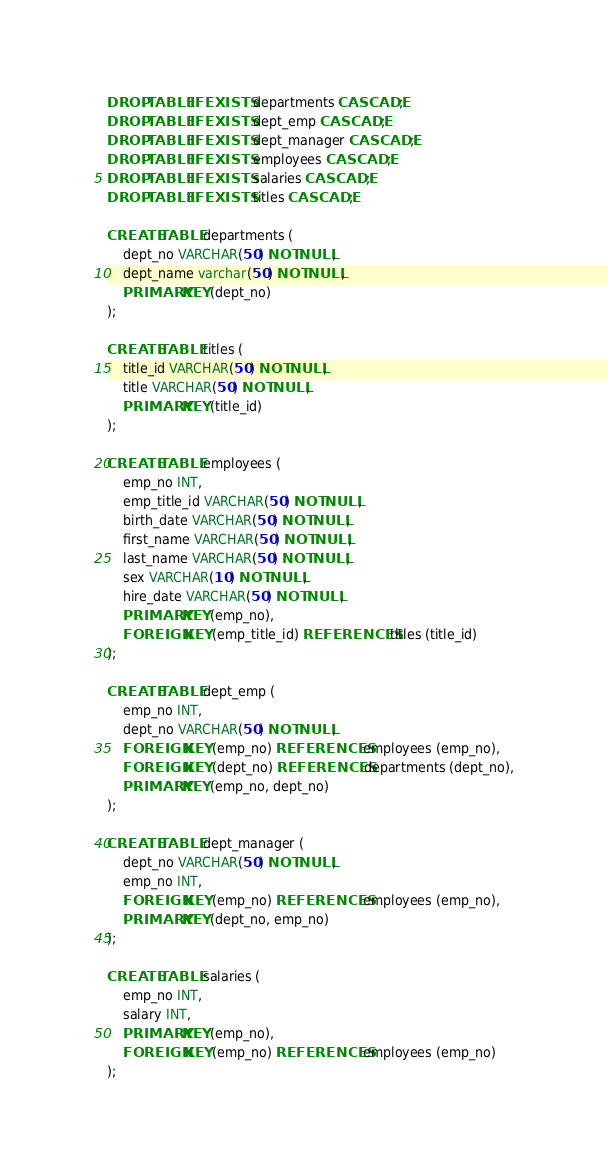<code> <loc_0><loc_0><loc_500><loc_500><_SQL_>DROP TABLE IF EXISTS departments CASCADE;
DROP TABLE IF EXISTS dept_emp CASCADE;
DROP TABLE IF EXISTS dept_manager CASCADE;
DROP TABLE IF EXISTS employees CASCADE;
DROP TABLE IF EXISTS salaries CASCADE;
DROP TABLE IF EXISTS titles CASCADE;

CREATE TABLE departments (
    dept_no VARCHAR(50) NOT NULL,
    dept_name varchar(50) NOT NULL,
	PRIMARY KEY (dept_no)
);

CREATE TABLE titles (
    title_id VARCHAR(50) NOT NULL,
    title VARCHAR(50) NOT NULL,
	PRIMARY KEY (title_id)
);

CREATE TABLE employees (
    emp_no INT,
    emp_title_id VARCHAR(50) NOT NULL,
    birth_date VARCHAR(50) NOT NULL,
    first_name VARCHAR(50) NOT NULL,
    last_name VARCHAR(50) NOT NULL,
    sex VARCHAR(10) NOT NULL,
    hire_date VARCHAR(50) NOT NULL,
	PRIMARY KEY (emp_no),
	FOREIGN KEY (emp_title_id) REFERENCES titles (title_id)
);

CREATE TABLE dept_emp (
    emp_no INT,
    dept_no VARCHAR(50) NOT NULL,
	FOREIGN KEY (emp_no) REFERENCES employees (emp_no),
	FOREIGN KEY (dept_no) REFERENCES departments (dept_no),
	PRIMARY KEY (emp_no, dept_no)
);

CREATE TABLE dept_manager (
    dept_no VARCHAR(50) NOT NULL,
	emp_no INT,
	FOREIGN KEY (emp_no) REFERENCES employees (emp_no),
	PRIMARY KEY (dept_no, emp_no)
);

CREATE TABLE salaries (
    emp_no INT,
    salary INT,
	PRIMARY KEY (emp_no),
	FOREIGN KEY (emp_no) REFERENCES employees (emp_no)
);



</code> 